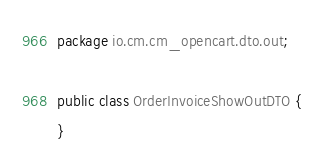<code> <loc_0><loc_0><loc_500><loc_500><_Java_>package io.cm.cm_opencart.dto.out;

public class OrderInvoiceShowOutDTO {
}
</code> 